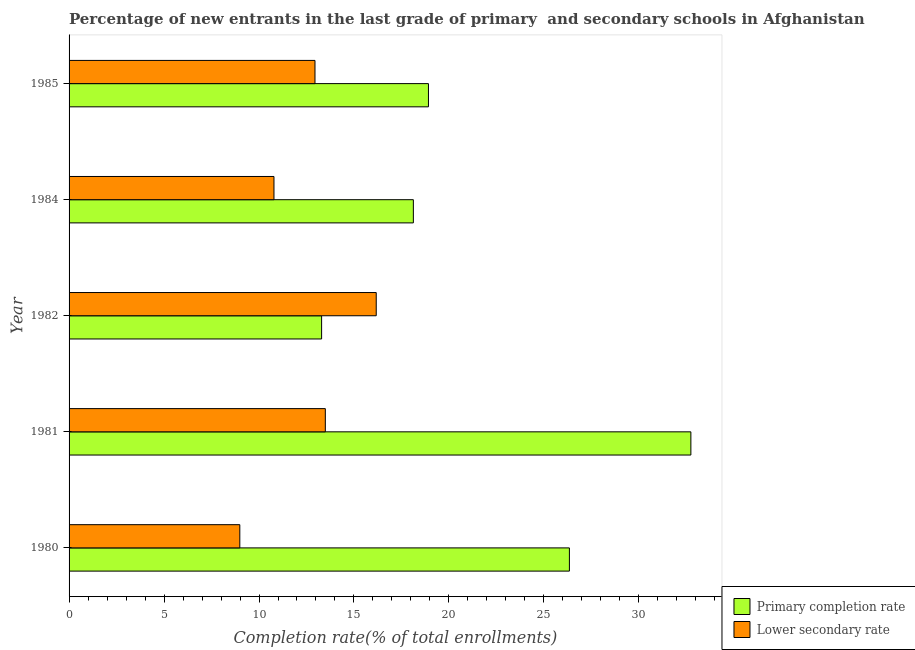Are the number of bars per tick equal to the number of legend labels?
Your answer should be very brief. Yes. What is the label of the 5th group of bars from the top?
Your answer should be compact. 1980. In how many cases, is the number of bars for a given year not equal to the number of legend labels?
Make the answer very short. 0. What is the completion rate in secondary schools in 1980?
Your answer should be compact. 8.99. Across all years, what is the maximum completion rate in secondary schools?
Ensure brevity in your answer.  16.17. Across all years, what is the minimum completion rate in primary schools?
Ensure brevity in your answer.  13.3. In which year was the completion rate in secondary schools minimum?
Make the answer very short. 1980. What is the total completion rate in primary schools in the graph?
Your response must be concise. 109.42. What is the difference between the completion rate in primary schools in 1981 and that in 1982?
Offer a terse response. 19.44. What is the difference between the completion rate in primary schools in 1981 and the completion rate in secondary schools in 1984?
Give a very brief answer. 21.95. What is the average completion rate in primary schools per year?
Your response must be concise. 21.89. In the year 1982, what is the difference between the completion rate in secondary schools and completion rate in primary schools?
Offer a very short reply. 2.88. What is the ratio of the completion rate in secondary schools in 1981 to that in 1982?
Keep it short and to the point. 0.83. Is the completion rate in secondary schools in 1984 less than that in 1985?
Your answer should be very brief. Yes. What is the difference between the highest and the second highest completion rate in primary schools?
Give a very brief answer. 6.39. What is the difference between the highest and the lowest completion rate in primary schools?
Give a very brief answer. 19.44. In how many years, is the completion rate in secondary schools greater than the average completion rate in secondary schools taken over all years?
Make the answer very short. 3. What does the 1st bar from the top in 1982 represents?
Make the answer very short. Lower secondary rate. What does the 1st bar from the bottom in 1984 represents?
Provide a succinct answer. Primary completion rate. Are all the bars in the graph horizontal?
Give a very brief answer. Yes. How many years are there in the graph?
Your response must be concise. 5. Are the values on the major ticks of X-axis written in scientific E-notation?
Your answer should be very brief. No. Does the graph contain any zero values?
Your answer should be very brief. No. Where does the legend appear in the graph?
Your answer should be very brief. Bottom right. How many legend labels are there?
Your answer should be compact. 2. What is the title of the graph?
Provide a short and direct response. Percentage of new entrants in the last grade of primary  and secondary schools in Afghanistan. What is the label or title of the X-axis?
Give a very brief answer. Completion rate(% of total enrollments). What is the Completion rate(% of total enrollments) in Primary completion rate in 1980?
Provide a succinct answer. 26.34. What is the Completion rate(% of total enrollments) in Lower secondary rate in 1980?
Keep it short and to the point. 8.99. What is the Completion rate(% of total enrollments) in Primary completion rate in 1981?
Ensure brevity in your answer.  32.74. What is the Completion rate(% of total enrollments) in Lower secondary rate in 1981?
Ensure brevity in your answer.  13.49. What is the Completion rate(% of total enrollments) in Primary completion rate in 1982?
Keep it short and to the point. 13.3. What is the Completion rate(% of total enrollments) in Lower secondary rate in 1982?
Your answer should be compact. 16.17. What is the Completion rate(% of total enrollments) of Primary completion rate in 1984?
Your answer should be very brief. 18.13. What is the Completion rate(% of total enrollments) of Lower secondary rate in 1984?
Offer a very short reply. 10.79. What is the Completion rate(% of total enrollments) of Primary completion rate in 1985?
Make the answer very short. 18.92. What is the Completion rate(% of total enrollments) in Lower secondary rate in 1985?
Your answer should be very brief. 12.95. Across all years, what is the maximum Completion rate(% of total enrollments) in Primary completion rate?
Your response must be concise. 32.74. Across all years, what is the maximum Completion rate(% of total enrollments) of Lower secondary rate?
Provide a succinct answer. 16.17. Across all years, what is the minimum Completion rate(% of total enrollments) of Primary completion rate?
Your response must be concise. 13.3. Across all years, what is the minimum Completion rate(% of total enrollments) of Lower secondary rate?
Your answer should be compact. 8.99. What is the total Completion rate(% of total enrollments) of Primary completion rate in the graph?
Your response must be concise. 109.42. What is the total Completion rate(% of total enrollments) in Lower secondary rate in the graph?
Provide a short and direct response. 62.39. What is the difference between the Completion rate(% of total enrollments) in Primary completion rate in 1980 and that in 1981?
Your answer should be very brief. -6.4. What is the difference between the Completion rate(% of total enrollments) in Lower secondary rate in 1980 and that in 1981?
Make the answer very short. -4.5. What is the difference between the Completion rate(% of total enrollments) of Primary completion rate in 1980 and that in 1982?
Provide a succinct answer. 13.05. What is the difference between the Completion rate(% of total enrollments) in Lower secondary rate in 1980 and that in 1982?
Give a very brief answer. -7.18. What is the difference between the Completion rate(% of total enrollments) in Primary completion rate in 1980 and that in 1984?
Provide a short and direct response. 8.22. What is the difference between the Completion rate(% of total enrollments) in Lower secondary rate in 1980 and that in 1984?
Your response must be concise. -1.8. What is the difference between the Completion rate(% of total enrollments) in Primary completion rate in 1980 and that in 1985?
Give a very brief answer. 7.42. What is the difference between the Completion rate(% of total enrollments) of Lower secondary rate in 1980 and that in 1985?
Ensure brevity in your answer.  -3.96. What is the difference between the Completion rate(% of total enrollments) of Primary completion rate in 1981 and that in 1982?
Keep it short and to the point. 19.44. What is the difference between the Completion rate(% of total enrollments) of Lower secondary rate in 1981 and that in 1982?
Give a very brief answer. -2.68. What is the difference between the Completion rate(% of total enrollments) of Primary completion rate in 1981 and that in 1984?
Give a very brief answer. 14.61. What is the difference between the Completion rate(% of total enrollments) of Lower secondary rate in 1981 and that in 1984?
Your answer should be very brief. 2.7. What is the difference between the Completion rate(% of total enrollments) of Primary completion rate in 1981 and that in 1985?
Offer a very short reply. 13.82. What is the difference between the Completion rate(% of total enrollments) of Lower secondary rate in 1981 and that in 1985?
Offer a terse response. 0.54. What is the difference between the Completion rate(% of total enrollments) of Primary completion rate in 1982 and that in 1984?
Ensure brevity in your answer.  -4.83. What is the difference between the Completion rate(% of total enrollments) in Lower secondary rate in 1982 and that in 1984?
Ensure brevity in your answer.  5.38. What is the difference between the Completion rate(% of total enrollments) in Primary completion rate in 1982 and that in 1985?
Give a very brief answer. -5.63. What is the difference between the Completion rate(% of total enrollments) in Lower secondary rate in 1982 and that in 1985?
Offer a terse response. 3.22. What is the difference between the Completion rate(% of total enrollments) of Primary completion rate in 1984 and that in 1985?
Offer a very short reply. -0.79. What is the difference between the Completion rate(% of total enrollments) in Lower secondary rate in 1984 and that in 1985?
Your answer should be compact. -2.16. What is the difference between the Completion rate(% of total enrollments) in Primary completion rate in 1980 and the Completion rate(% of total enrollments) in Lower secondary rate in 1981?
Provide a short and direct response. 12.85. What is the difference between the Completion rate(% of total enrollments) in Primary completion rate in 1980 and the Completion rate(% of total enrollments) in Lower secondary rate in 1982?
Provide a succinct answer. 10.17. What is the difference between the Completion rate(% of total enrollments) of Primary completion rate in 1980 and the Completion rate(% of total enrollments) of Lower secondary rate in 1984?
Give a very brief answer. 15.55. What is the difference between the Completion rate(% of total enrollments) of Primary completion rate in 1980 and the Completion rate(% of total enrollments) of Lower secondary rate in 1985?
Your answer should be very brief. 13.4. What is the difference between the Completion rate(% of total enrollments) of Primary completion rate in 1981 and the Completion rate(% of total enrollments) of Lower secondary rate in 1982?
Give a very brief answer. 16.57. What is the difference between the Completion rate(% of total enrollments) in Primary completion rate in 1981 and the Completion rate(% of total enrollments) in Lower secondary rate in 1984?
Provide a short and direct response. 21.95. What is the difference between the Completion rate(% of total enrollments) of Primary completion rate in 1981 and the Completion rate(% of total enrollments) of Lower secondary rate in 1985?
Your response must be concise. 19.79. What is the difference between the Completion rate(% of total enrollments) in Primary completion rate in 1982 and the Completion rate(% of total enrollments) in Lower secondary rate in 1984?
Keep it short and to the point. 2.51. What is the difference between the Completion rate(% of total enrollments) of Primary completion rate in 1982 and the Completion rate(% of total enrollments) of Lower secondary rate in 1985?
Your response must be concise. 0.35. What is the difference between the Completion rate(% of total enrollments) in Primary completion rate in 1984 and the Completion rate(% of total enrollments) in Lower secondary rate in 1985?
Ensure brevity in your answer.  5.18. What is the average Completion rate(% of total enrollments) in Primary completion rate per year?
Offer a very short reply. 21.89. What is the average Completion rate(% of total enrollments) in Lower secondary rate per year?
Offer a terse response. 12.48. In the year 1980, what is the difference between the Completion rate(% of total enrollments) of Primary completion rate and Completion rate(% of total enrollments) of Lower secondary rate?
Your answer should be compact. 17.35. In the year 1981, what is the difference between the Completion rate(% of total enrollments) in Primary completion rate and Completion rate(% of total enrollments) in Lower secondary rate?
Provide a succinct answer. 19.25. In the year 1982, what is the difference between the Completion rate(% of total enrollments) of Primary completion rate and Completion rate(% of total enrollments) of Lower secondary rate?
Your answer should be very brief. -2.88. In the year 1984, what is the difference between the Completion rate(% of total enrollments) of Primary completion rate and Completion rate(% of total enrollments) of Lower secondary rate?
Your response must be concise. 7.34. In the year 1985, what is the difference between the Completion rate(% of total enrollments) of Primary completion rate and Completion rate(% of total enrollments) of Lower secondary rate?
Provide a short and direct response. 5.97. What is the ratio of the Completion rate(% of total enrollments) in Primary completion rate in 1980 to that in 1981?
Provide a short and direct response. 0.8. What is the ratio of the Completion rate(% of total enrollments) in Lower secondary rate in 1980 to that in 1981?
Offer a terse response. 0.67. What is the ratio of the Completion rate(% of total enrollments) of Primary completion rate in 1980 to that in 1982?
Give a very brief answer. 1.98. What is the ratio of the Completion rate(% of total enrollments) in Lower secondary rate in 1980 to that in 1982?
Offer a terse response. 0.56. What is the ratio of the Completion rate(% of total enrollments) in Primary completion rate in 1980 to that in 1984?
Ensure brevity in your answer.  1.45. What is the ratio of the Completion rate(% of total enrollments) in Lower secondary rate in 1980 to that in 1984?
Your response must be concise. 0.83. What is the ratio of the Completion rate(% of total enrollments) of Primary completion rate in 1980 to that in 1985?
Provide a short and direct response. 1.39. What is the ratio of the Completion rate(% of total enrollments) of Lower secondary rate in 1980 to that in 1985?
Offer a very short reply. 0.69. What is the ratio of the Completion rate(% of total enrollments) in Primary completion rate in 1981 to that in 1982?
Make the answer very short. 2.46. What is the ratio of the Completion rate(% of total enrollments) of Lower secondary rate in 1981 to that in 1982?
Your answer should be very brief. 0.83. What is the ratio of the Completion rate(% of total enrollments) of Primary completion rate in 1981 to that in 1984?
Offer a very short reply. 1.81. What is the ratio of the Completion rate(% of total enrollments) in Lower secondary rate in 1981 to that in 1984?
Offer a terse response. 1.25. What is the ratio of the Completion rate(% of total enrollments) in Primary completion rate in 1981 to that in 1985?
Your answer should be very brief. 1.73. What is the ratio of the Completion rate(% of total enrollments) in Lower secondary rate in 1981 to that in 1985?
Your answer should be compact. 1.04. What is the ratio of the Completion rate(% of total enrollments) in Primary completion rate in 1982 to that in 1984?
Make the answer very short. 0.73. What is the ratio of the Completion rate(% of total enrollments) in Lower secondary rate in 1982 to that in 1984?
Provide a succinct answer. 1.5. What is the ratio of the Completion rate(% of total enrollments) of Primary completion rate in 1982 to that in 1985?
Your answer should be compact. 0.7. What is the ratio of the Completion rate(% of total enrollments) of Lower secondary rate in 1982 to that in 1985?
Provide a succinct answer. 1.25. What is the ratio of the Completion rate(% of total enrollments) of Primary completion rate in 1984 to that in 1985?
Keep it short and to the point. 0.96. What is the ratio of the Completion rate(% of total enrollments) in Lower secondary rate in 1984 to that in 1985?
Your answer should be very brief. 0.83. What is the difference between the highest and the second highest Completion rate(% of total enrollments) in Primary completion rate?
Your answer should be compact. 6.4. What is the difference between the highest and the second highest Completion rate(% of total enrollments) of Lower secondary rate?
Offer a terse response. 2.68. What is the difference between the highest and the lowest Completion rate(% of total enrollments) of Primary completion rate?
Keep it short and to the point. 19.44. What is the difference between the highest and the lowest Completion rate(% of total enrollments) in Lower secondary rate?
Provide a succinct answer. 7.18. 